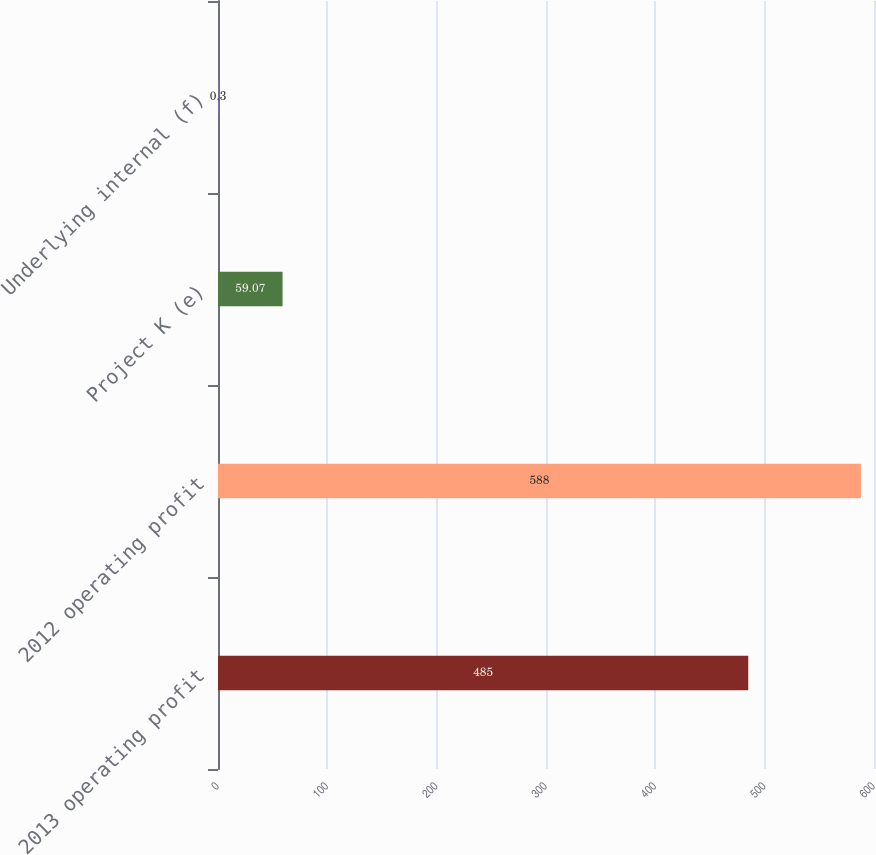Convert chart to OTSL. <chart><loc_0><loc_0><loc_500><loc_500><bar_chart><fcel>2013 operating profit<fcel>2012 operating profit<fcel>Project K (e)<fcel>Underlying internal (f)<nl><fcel>485<fcel>588<fcel>59.07<fcel>0.3<nl></chart> 